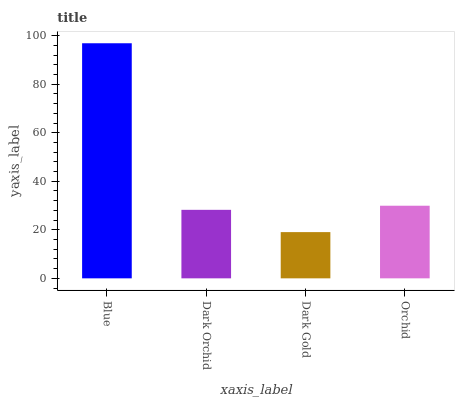Is Dark Gold the minimum?
Answer yes or no. Yes. Is Blue the maximum?
Answer yes or no. Yes. Is Dark Orchid the minimum?
Answer yes or no. No. Is Dark Orchid the maximum?
Answer yes or no. No. Is Blue greater than Dark Orchid?
Answer yes or no. Yes. Is Dark Orchid less than Blue?
Answer yes or no. Yes. Is Dark Orchid greater than Blue?
Answer yes or no. No. Is Blue less than Dark Orchid?
Answer yes or no. No. Is Orchid the high median?
Answer yes or no. Yes. Is Dark Orchid the low median?
Answer yes or no. Yes. Is Dark Gold the high median?
Answer yes or no. No. Is Dark Gold the low median?
Answer yes or no. No. 